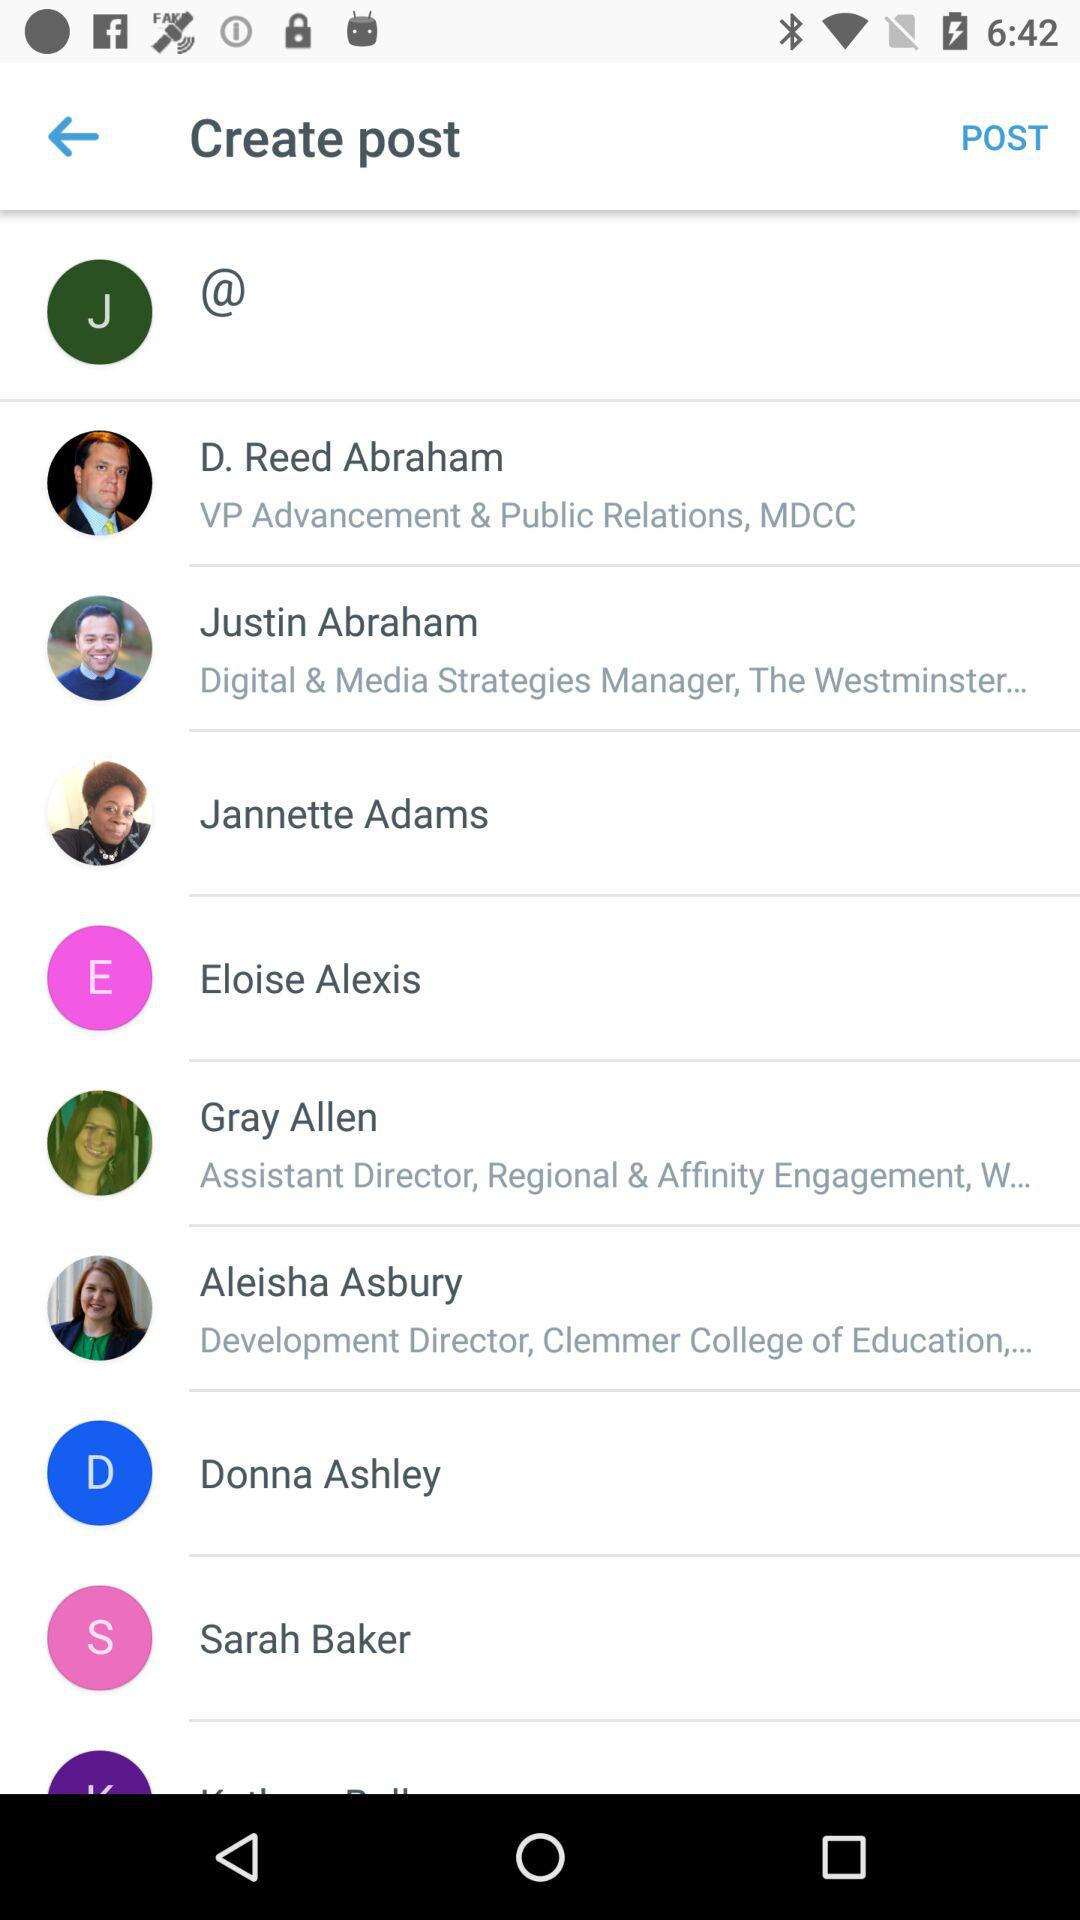What is Sarah Baker's profession?
When the provided information is insufficient, respond with <no answer>. <no answer> 